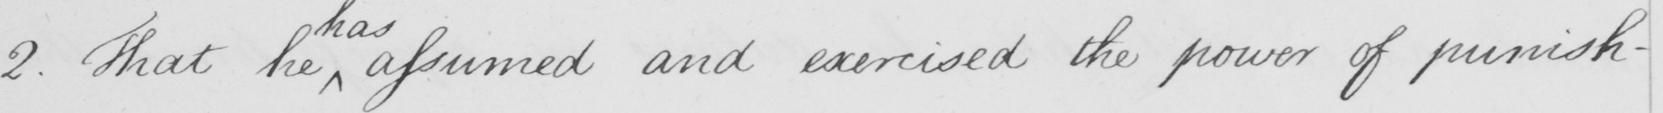Can you read and transcribe this handwriting? 2 . The he assumed and exercised the power of punish- 